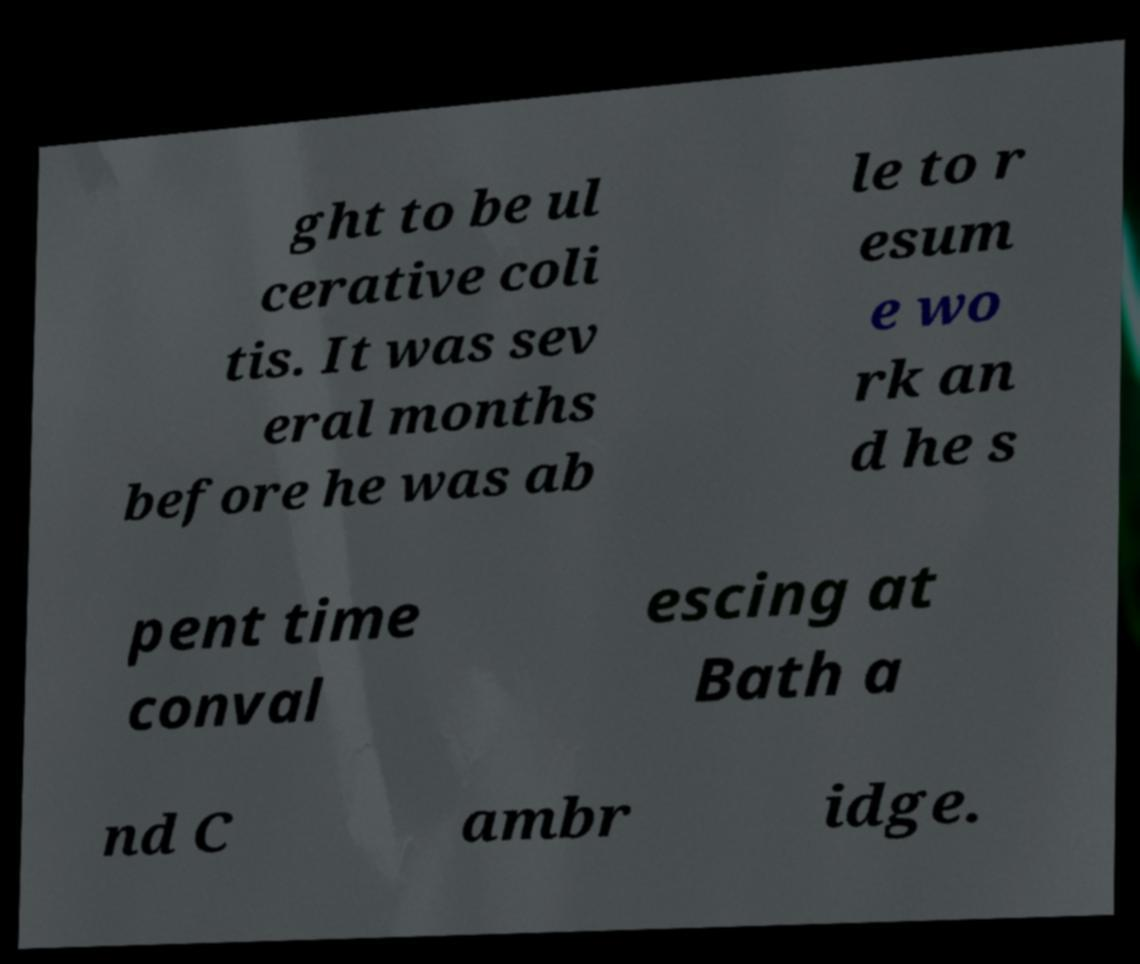What messages or text are displayed in this image? I need them in a readable, typed format. ght to be ul cerative coli tis. It was sev eral months before he was ab le to r esum e wo rk an d he s pent time conval escing at Bath a nd C ambr idge. 